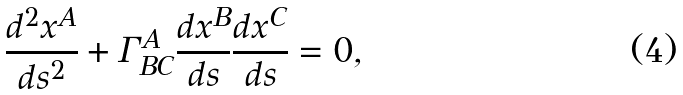<formula> <loc_0><loc_0><loc_500><loc_500>\frac { d ^ { 2 } x ^ { A } } { d s ^ { 2 } } + \Gamma ^ { A } _ { B C } \frac { d x ^ { B } } { d s } \frac { d x ^ { C } } { d s } = 0 ,</formula> 